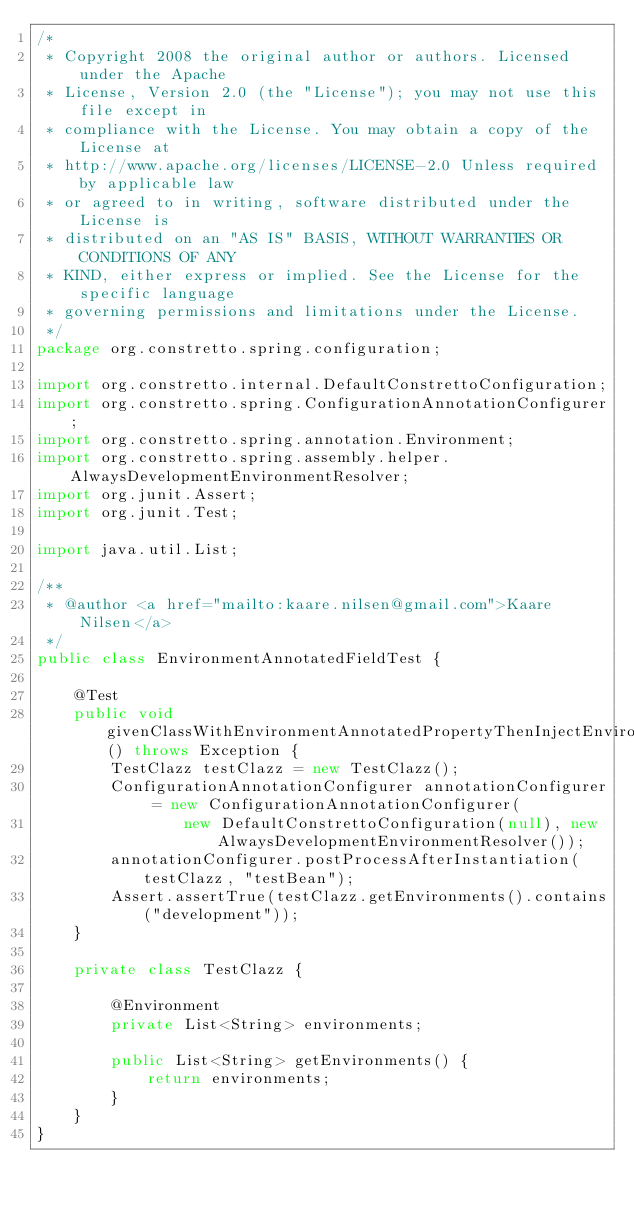Convert code to text. <code><loc_0><loc_0><loc_500><loc_500><_Java_>/*
 * Copyright 2008 the original author or authors. Licensed under the Apache
 * License, Version 2.0 (the "License"); you may not use this file except in
 * compliance with the License. You may obtain a copy of the License at
 * http://www.apache.org/licenses/LICENSE-2.0 Unless required by applicable law
 * or agreed to in writing, software distributed under the License is
 * distributed on an "AS IS" BASIS, WITHOUT WARRANTIES OR CONDITIONS OF ANY
 * KIND, either express or implied. See the License for the specific language
 * governing permissions and limitations under the License.
 */
package org.constretto.spring.configuration;

import org.constretto.internal.DefaultConstrettoConfiguration;
import org.constretto.spring.ConfigurationAnnotationConfigurer;
import org.constretto.spring.annotation.Environment;
import org.constretto.spring.assembly.helper.AlwaysDevelopmentEnvironmentResolver;
import org.junit.Assert;
import org.junit.Test;

import java.util.List;

/**
 * @author <a href="mailto:kaare.nilsen@gmail.com">Kaare Nilsen</a>
 */
public class EnvironmentAnnotatedFieldTest {

    @Test
    public void givenClassWithEnvironmentAnnotatedPropertyThenInjectEnvironment() throws Exception {
        TestClazz testClazz = new TestClazz();
        ConfigurationAnnotationConfigurer annotationConfigurer = new ConfigurationAnnotationConfigurer(
                new DefaultConstrettoConfiguration(null), new AlwaysDevelopmentEnvironmentResolver());
        annotationConfigurer.postProcessAfterInstantiation(testClazz, "testBean");
        Assert.assertTrue(testClazz.getEnvironments().contains("development"));
    }

    private class TestClazz {

        @Environment
        private List<String> environments;

        public List<String> getEnvironments() {
            return environments;
        }
    }
}
</code> 